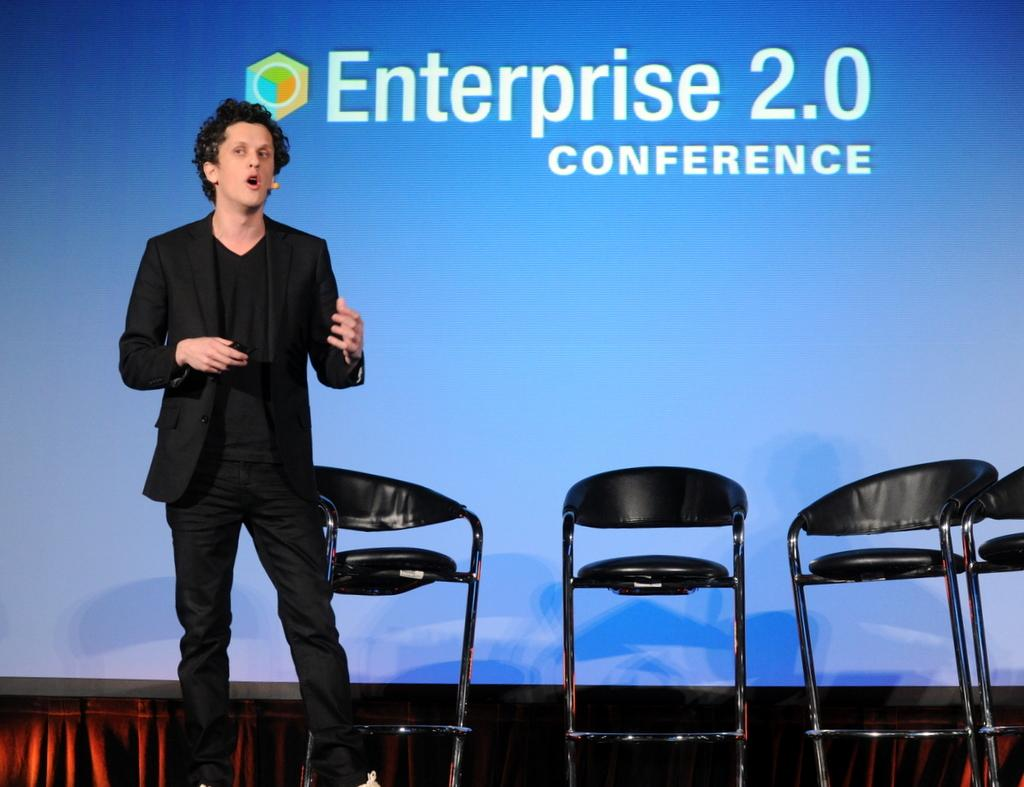Who is the person in the image? There is a man in the image. What is the man wearing? The man is wearing a blazer. What is the man doing in the image? The man is talking on a microphone. How many chairs are beside the man? There are four chairs beside the man. What can be seen in the background of the image? There is a screen visible in the background of the image. What type of sticks are the squirrels holding in the image? There are no squirrels or sticks present in the image. What time of day is it in the image? The time of day cannot be determined from the image alone. 